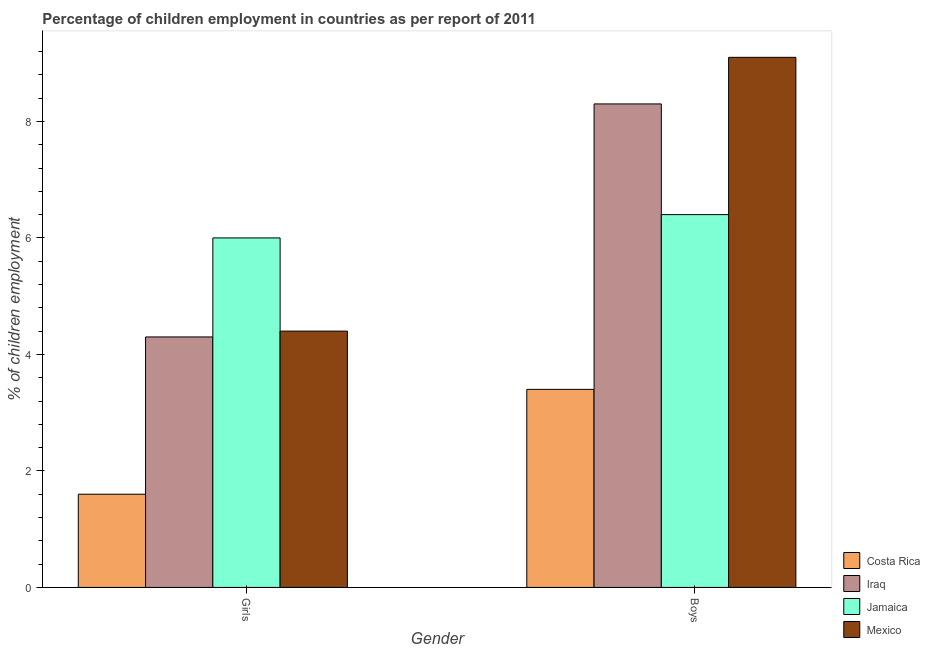How many different coloured bars are there?
Your answer should be very brief. 4. How many groups of bars are there?
Your answer should be very brief. 2. Are the number of bars on each tick of the X-axis equal?
Give a very brief answer. Yes. How many bars are there on the 1st tick from the left?
Ensure brevity in your answer.  4. How many bars are there on the 1st tick from the right?
Your response must be concise. 4. What is the label of the 2nd group of bars from the left?
Give a very brief answer. Boys. Across all countries, what is the maximum percentage of employed girls?
Provide a succinct answer. 6. In which country was the percentage of employed girls maximum?
Your answer should be compact. Jamaica. What is the total percentage of employed boys in the graph?
Ensure brevity in your answer.  27.2. What is the difference between the percentage of employed boys in Iraq and the percentage of employed girls in Mexico?
Your response must be concise. 3.9. What is the average percentage of employed boys per country?
Ensure brevity in your answer.  6.8. What is the difference between the percentage of employed girls and percentage of employed boys in Costa Rica?
Your answer should be compact. -1.8. In how many countries, is the percentage of employed girls greater than 5.6 %?
Ensure brevity in your answer.  1. What is the ratio of the percentage of employed boys in Jamaica to that in Mexico?
Keep it short and to the point. 0.7. What does the 1st bar from the right in Girls represents?
Make the answer very short. Mexico. How many bars are there?
Provide a short and direct response. 8. Are the values on the major ticks of Y-axis written in scientific E-notation?
Offer a very short reply. No. Does the graph contain grids?
Keep it short and to the point. No. How many legend labels are there?
Make the answer very short. 4. What is the title of the graph?
Provide a short and direct response. Percentage of children employment in countries as per report of 2011. What is the label or title of the X-axis?
Your response must be concise. Gender. What is the label or title of the Y-axis?
Offer a very short reply. % of children employment. What is the % of children employment in Mexico in Girls?
Give a very brief answer. 4.4. What is the % of children employment in Jamaica in Boys?
Provide a short and direct response. 6.4. Across all Gender, what is the maximum % of children employment in Iraq?
Ensure brevity in your answer.  8.3. Across all Gender, what is the maximum % of children employment of Mexico?
Ensure brevity in your answer.  9.1. Across all Gender, what is the minimum % of children employment in Costa Rica?
Ensure brevity in your answer.  1.6. Across all Gender, what is the minimum % of children employment in Jamaica?
Your answer should be compact. 6. Across all Gender, what is the minimum % of children employment in Mexico?
Your response must be concise. 4.4. What is the total % of children employment of Costa Rica in the graph?
Ensure brevity in your answer.  5. What is the total % of children employment in Iraq in the graph?
Your answer should be compact. 12.6. What is the total % of children employment in Jamaica in the graph?
Your answer should be compact. 12.4. What is the difference between the % of children employment of Iraq in Girls and that in Boys?
Offer a terse response. -4. What is the difference between the % of children employment in Mexico in Girls and that in Boys?
Provide a short and direct response. -4.7. What is the difference between the % of children employment in Costa Rica in Girls and the % of children employment in Iraq in Boys?
Your answer should be compact. -6.7. What is the difference between the % of children employment in Costa Rica in Girls and the % of children employment in Jamaica in Boys?
Provide a succinct answer. -4.8. What is the difference between the % of children employment in Jamaica in Girls and the % of children employment in Mexico in Boys?
Provide a short and direct response. -3.1. What is the average % of children employment of Costa Rica per Gender?
Your response must be concise. 2.5. What is the average % of children employment of Iraq per Gender?
Offer a terse response. 6.3. What is the average % of children employment in Jamaica per Gender?
Give a very brief answer. 6.2. What is the average % of children employment of Mexico per Gender?
Ensure brevity in your answer.  6.75. What is the difference between the % of children employment in Costa Rica and % of children employment in Jamaica in Girls?
Make the answer very short. -4.4. What is the difference between the % of children employment of Costa Rica and % of children employment of Mexico in Girls?
Make the answer very short. -2.8. What is the difference between the % of children employment in Iraq and % of children employment in Mexico in Girls?
Your answer should be very brief. -0.1. What is the difference between the % of children employment of Jamaica and % of children employment of Mexico in Girls?
Make the answer very short. 1.6. What is the difference between the % of children employment in Costa Rica and % of children employment in Iraq in Boys?
Make the answer very short. -4.9. What is the difference between the % of children employment of Iraq and % of children employment of Mexico in Boys?
Your answer should be compact. -0.8. What is the difference between the % of children employment of Jamaica and % of children employment of Mexico in Boys?
Give a very brief answer. -2.7. What is the ratio of the % of children employment in Costa Rica in Girls to that in Boys?
Provide a succinct answer. 0.47. What is the ratio of the % of children employment in Iraq in Girls to that in Boys?
Your answer should be very brief. 0.52. What is the ratio of the % of children employment of Mexico in Girls to that in Boys?
Give a very brief answer. 0.48. What is the difference between the highest and the second highest % of children employment of Costa Rica?
Your answer should be compact. 1.8. What is the difference between the highest and the second highest % of children employment in Mexico?
Your response must be concise. 4.7. What is the difference between the highest and the lowest % of children employment in Costa Rica?
Give a very brief answer. 1.8. What is the difference between the highest and the lowest % of children employment in Iraq?
Your response must be concise. 4. What is the difference between the highest and the lowest % of children employment in Jamaica?
Provide a succinct answer. 0.4. What is the difference between the highest and the lowest % of children employment in Mexico?
Your answer should be compact. 4.7. 